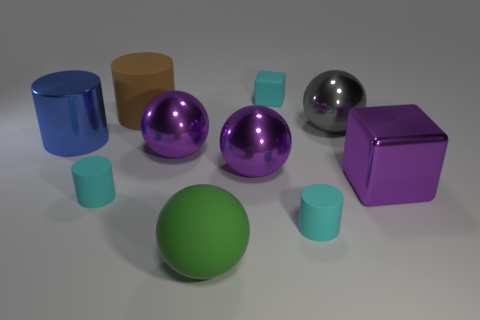What number of objects are metallic objects behind the blue shiny object or tiny blue metal cylinders?
Give a very brief answer. 1. The cube that is the same material as the large green sphere is what size?
Provide a short and direct response. Small. Do the brown thing and the cube behind the big gray thing have the same size?
Give a very brief answer. No. There is a thing that is both right of the big green matte object and behind the large gray shiny thing; what is its color?
Your response must be concise. Cyan. How many objects are either rubber objects that are in front of the large blue cylinder or tiny cyan matte objects right of the brown rubber thing?
Your response must be concise. 4. The big metal block that is to the right of the small rubber cylinder that is on the right side of the small cylinder to the left of the brown matte cylinder is what color?
Your answer should be very brief. Purple. Is there another large object that has the same shape as the blue shiny thing?
Give a very brief answer. Yes. How many small blue matte things are there?
Provide a succinct answer. 0. What is the shape of the green thing?
Your answer should be very brief. Sphere. What number of green objects are the same size as the brown matte cylinder?
Provide a short and direct response. 1. 